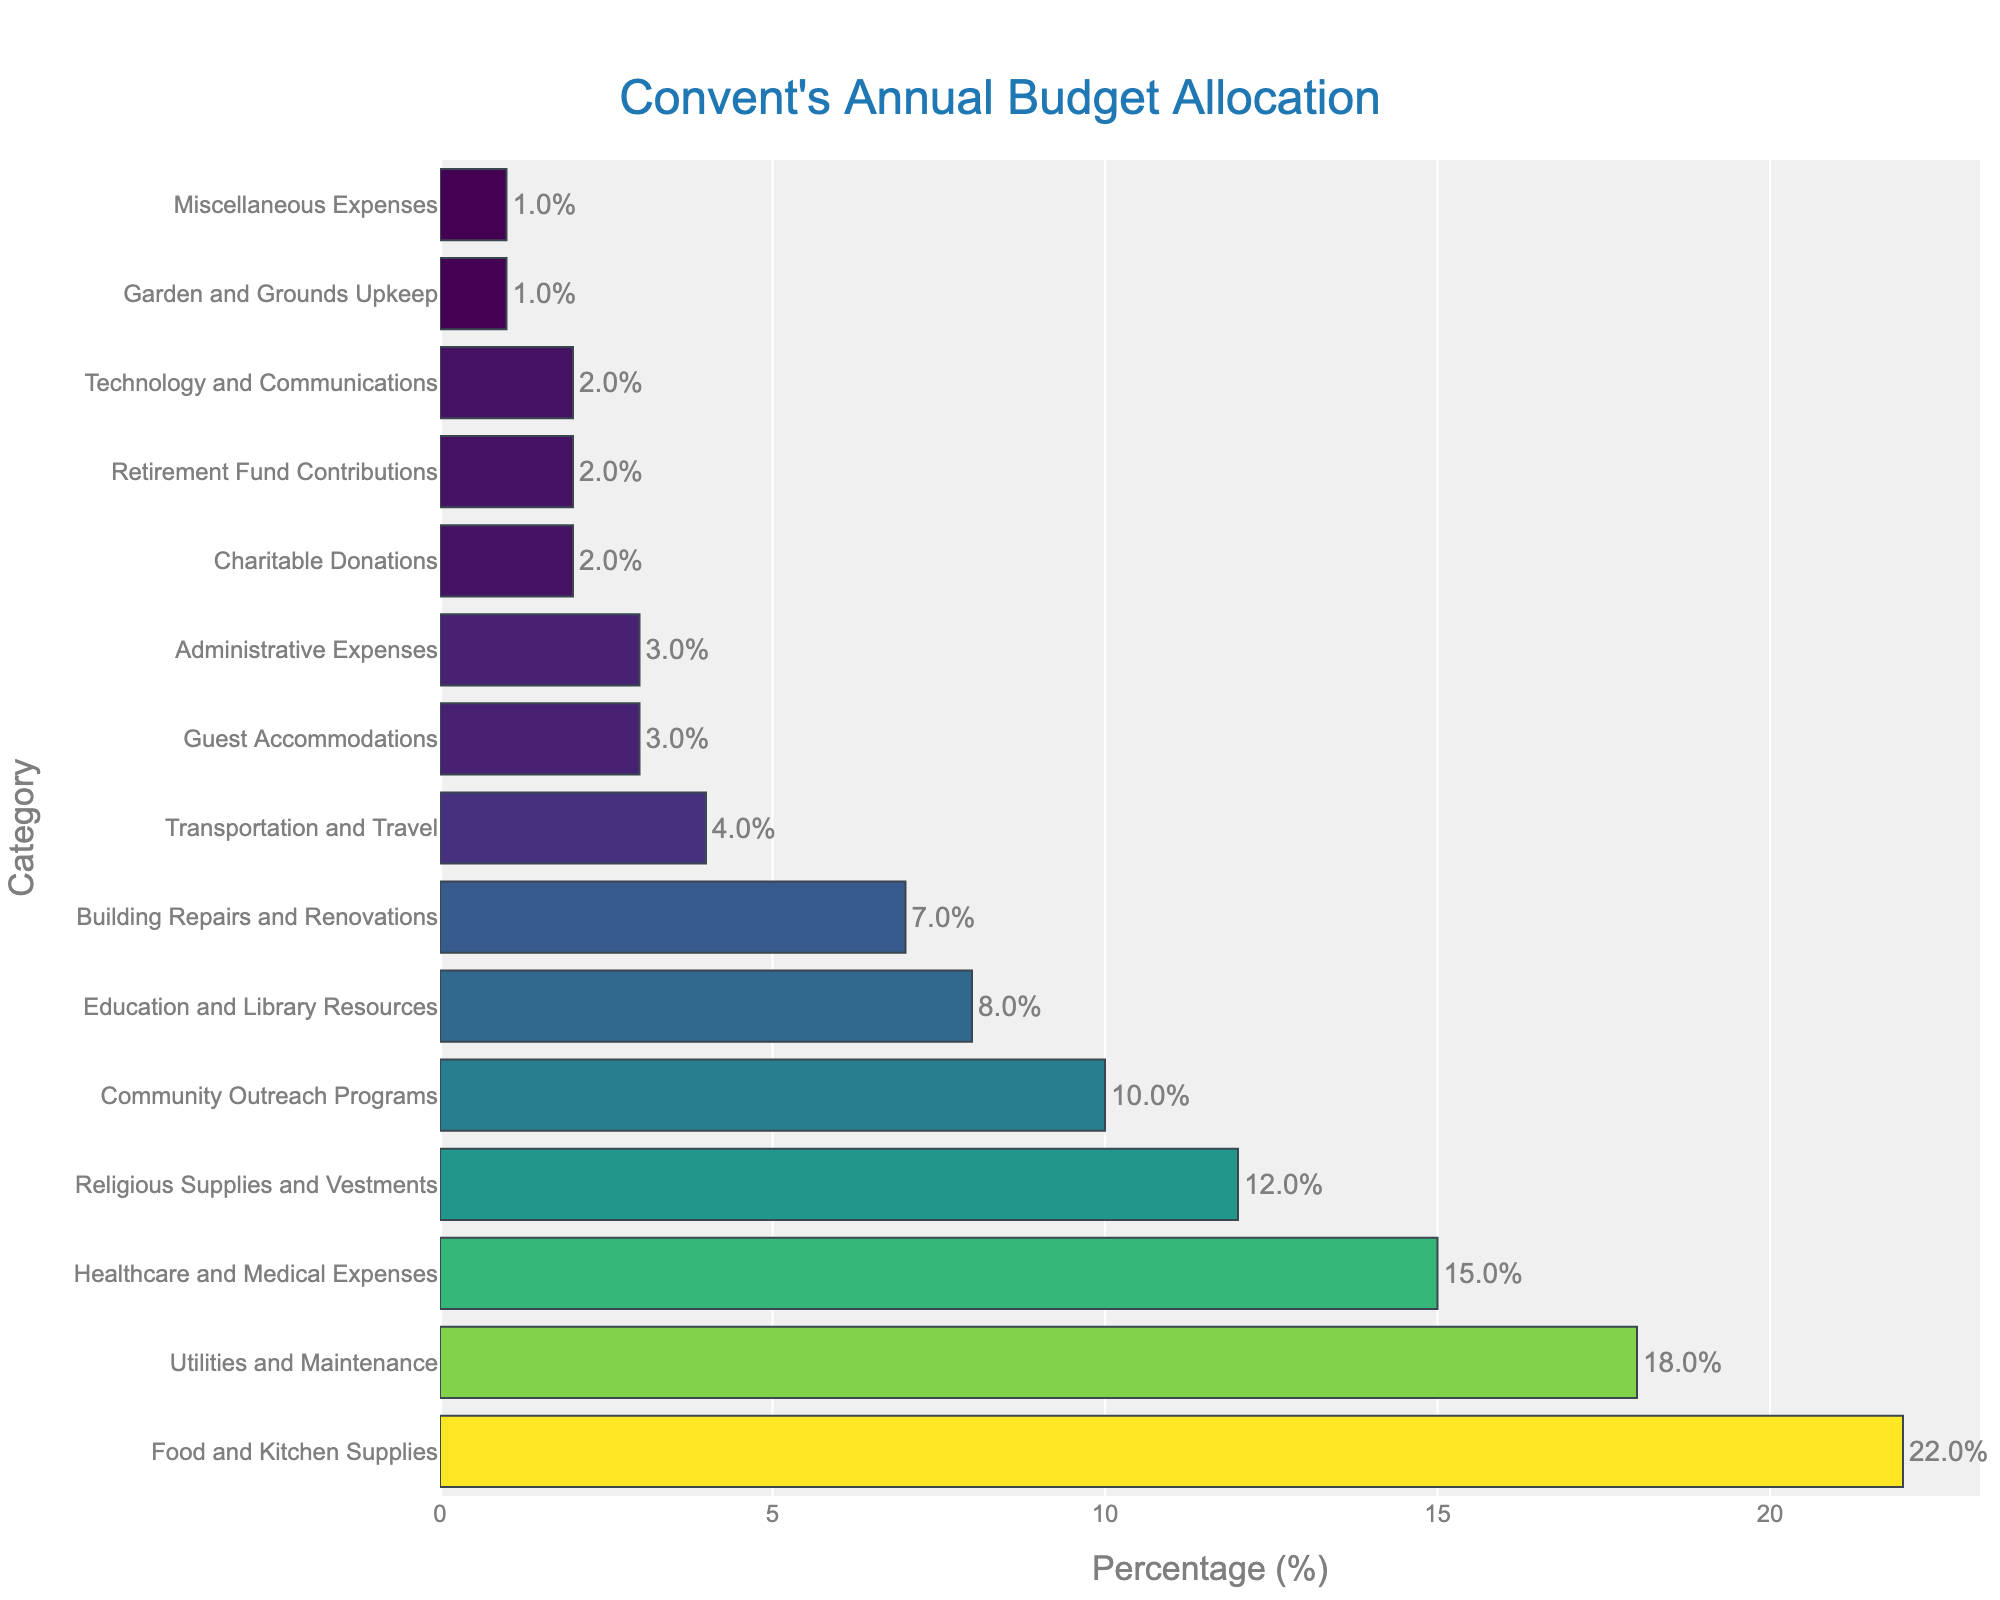Which category has the highest budget allocation? The highest bar indicates the category with the highest budget allocation. In this case, it is the bar labeled "Food and Kitchen Supplies" with 22%.
Answer: Food and Kitchen Supplies How much more is allocated to Utilities and Maintenance than to Healthcare and Medical Expenses? Utilities and Maintenance has 18%, while Healthcare and Medical Expenses has 15%. The difference is 18 - 15 = 3%.
Answer: 3% What is the combined budget allocation for Community Outreach Programs and Charitable Donations? Community Outreach Programs has 10% and Charitable Donations has 2%. Adding these two allocations, we get 10 + 2 = 12%.
Answer: 12% Is the percentage allocated to Retirement Fund Contributions greater than or less than the percentage allocated to Miscellaneous Expenses? Both categories have the same percentage allocated, which is 2% for Retirement Fund Contributions and 1% for Miscellaneous Expenses. 2% is greater than 1%.
Answer: Greater What fraction of the total budget does the Guest Accommodations category represent? Guest Accommodations accounts for 3% of the total budget. To convert it into a fraction out of 100, it represents 3/100 of the total budget.
Answer: 3/100 Does Education and Library Resources receive more allocation than Building Repairs and Renovations? Education and Library Resources has 8%, while Building Repairs and Renovations has 7%. Since 8% is greater than 7%, Education and Library Resources receives more allocation.
Answer: Yes What is the visual difference in the length of the bars for Transportation and Travel and Administrative Expenses? Both Transportation and Travel and Administrative Expenses have the same budget allocation of 3%, so their bar lengths will be equal.
Answer: Equal How much budget allocation is given to categories with percentages less than 5%? The categories with percentages less than 5% are Transportation and Travel (4%), Guest Accommodations (3%), Administrative Expenses (3%), Charitable Donations (2%), Retirement Fund Contributions (2%), Technology and Communications (2%), Garden and Grounds Upkeep (1%), and Miscellaneous Expenses (1%). Summing all these percentages: 4 + 3 + 3 + 2 + 2 + 2 + 1 + 1 = 18%.
Answer: 18% Which categories have a budget allocation of exactly 2%? The categories that have a budget allocation of exactly 2% are Charitable Donations, Retirement Fund Contributions, and Technology and Communications.
Answer: Charitable Donations, Retirement Fund Contributions, Technology and Communications 